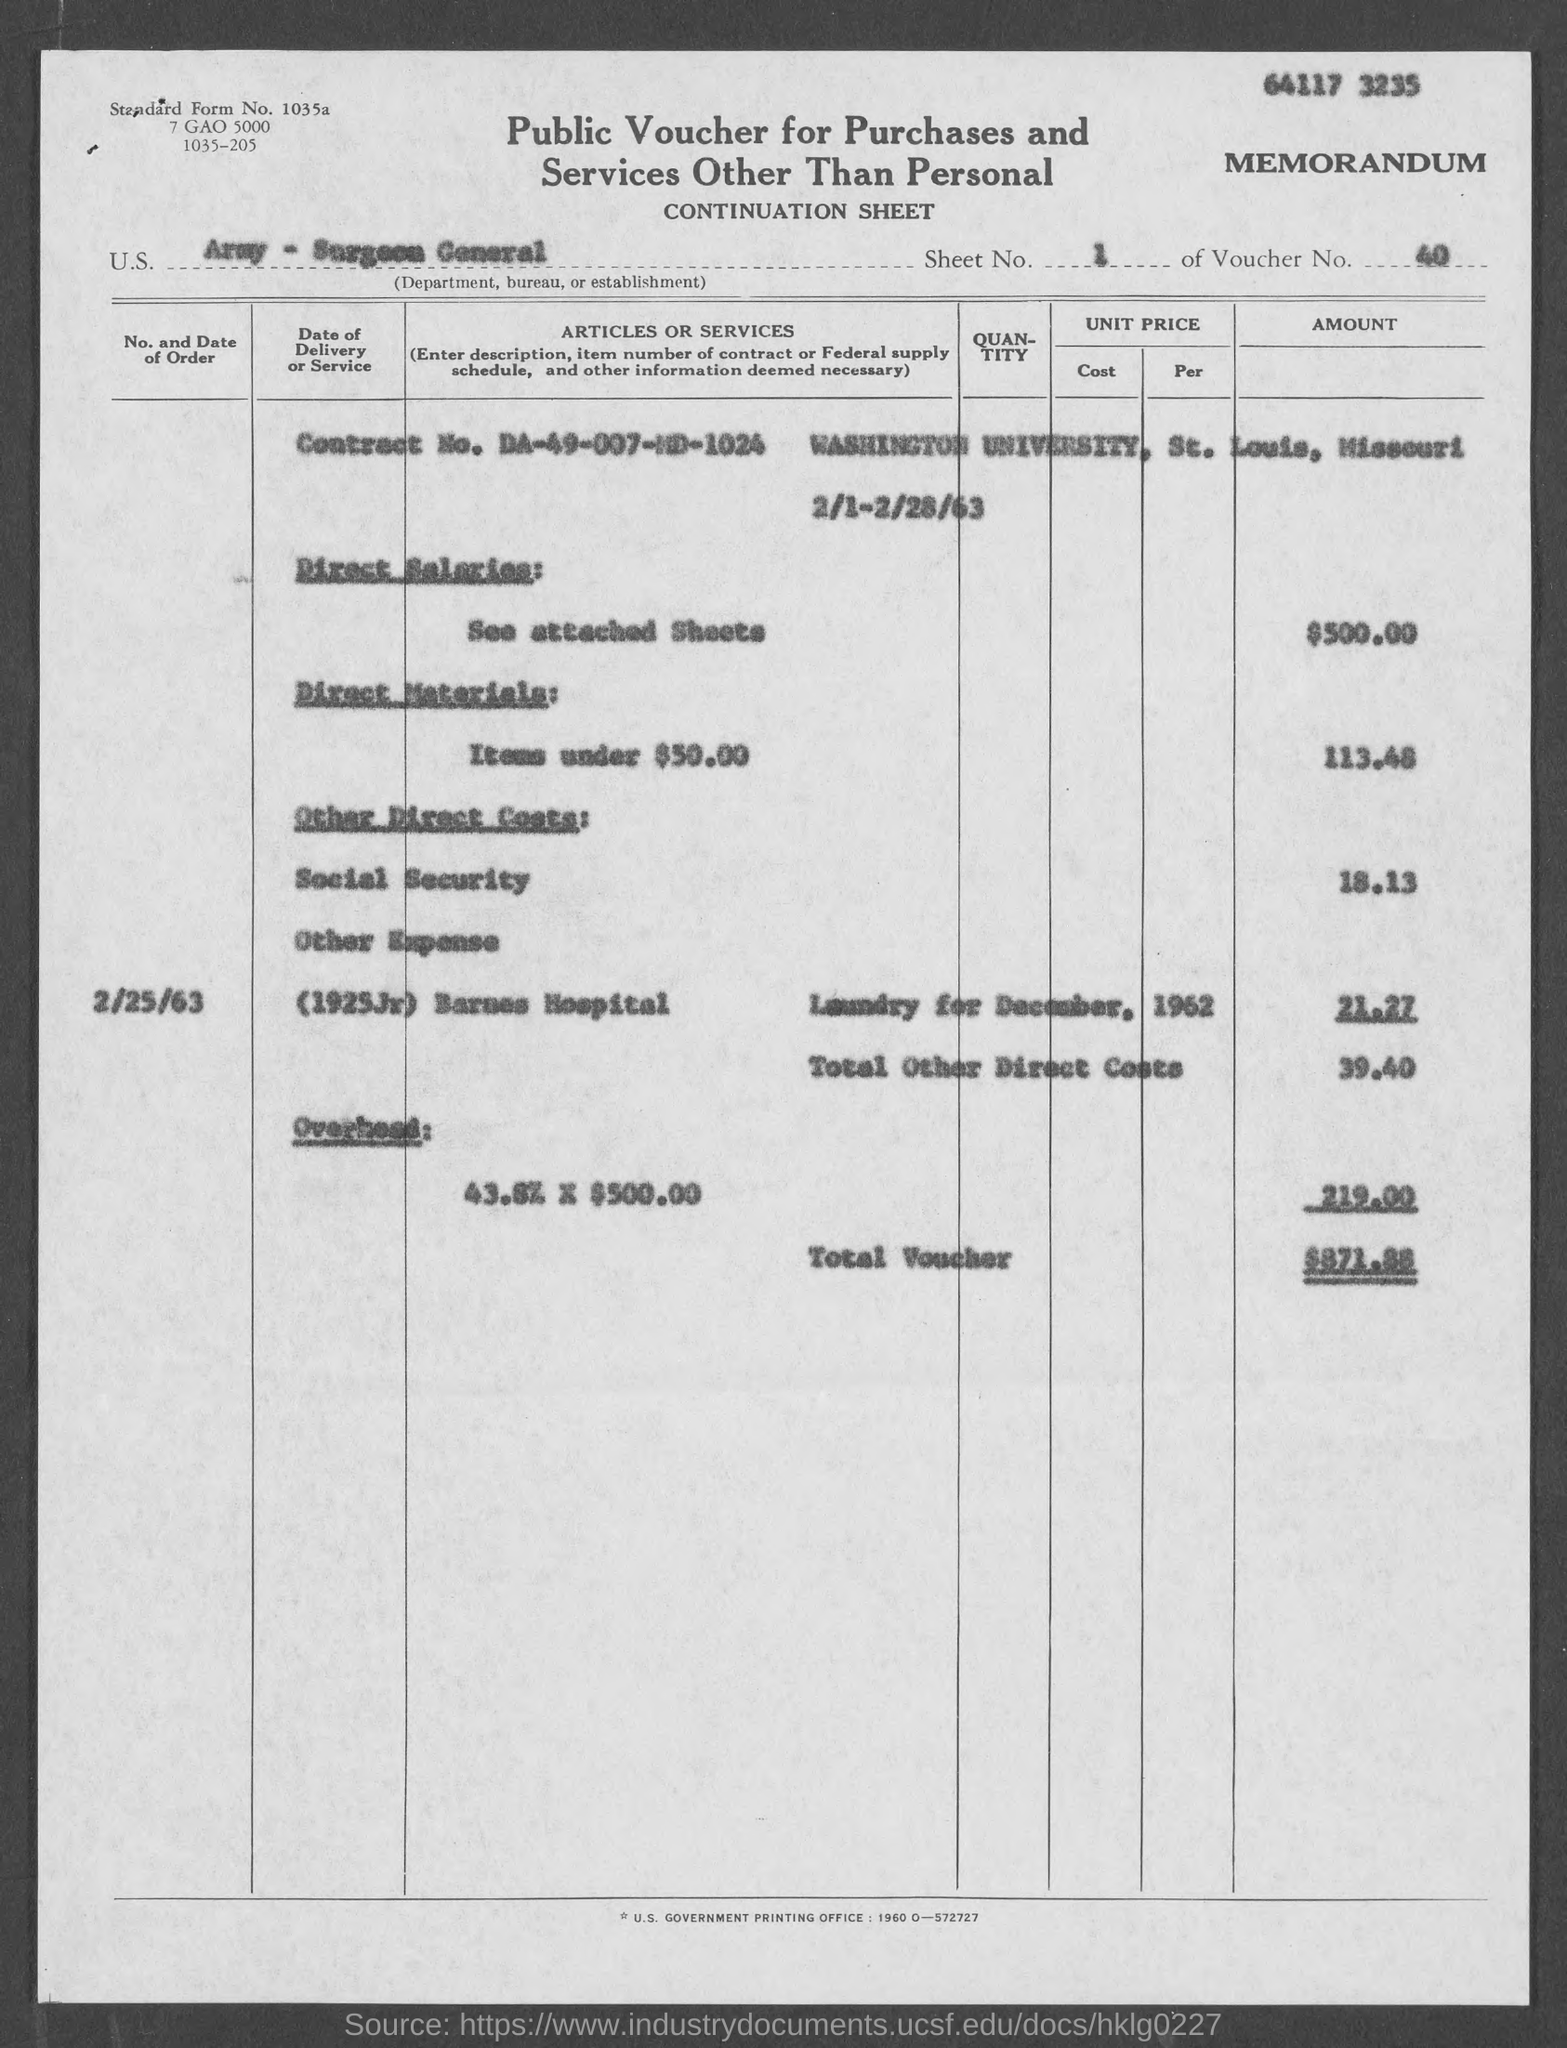Highlight a few significant elements in this photo. Washington University, located in the state of Missouri, is in the city of St. Louis. The voucher number is 40... The total voucher amount is $871.88. The standard form number is 1035a. What is the sheet number? This refers to the first sheet of several consecutive sheets, with each subsequent sheet having a number that is one higher than the previous one. 